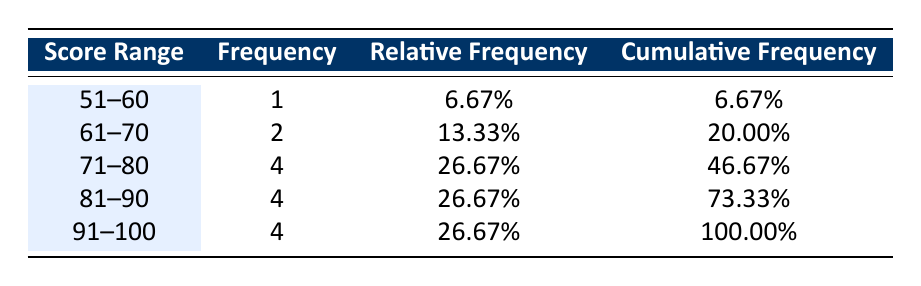What is the total number of students who scored between 81 and 90? Looking at the frequency column for the score range 81-90, there are 4 students.
Answer: 4 What percentage of students scored below 71? To find the percentage of students scored below 71, we need to sum the frequencies for score ranges 51-60 and 61-70, which adds up to 1 + 2 = 3 students. The relative frequency for these ranges is 20.00%. Thus, 3 students out of 15 total students is (3/15) * 100 = 20%.
Answer: 20.00% How many students scored 90 or higher? In the score ranges 91-100, there are 4 students. Specifically, the students who scored 90 or above include the ranges 91-100, which is 4 students total.
Answer: 4 Is it true that more students scored between 71 and 80 than those scored between 61 and 70? The frequency for the score range 71-80 is 4 students, while the frequency for the 61-70 range is 2 students. Since 4 is greater than 2, it is true.
Answer: Yes What is the cumulative frequency of students scoring above 70? To find this, we first identify the cumulative frequencies for the relevant score ranges: 71-80 (46.67%) and 81-90 (73.33%) and 91-100 (100.00%). Thus, the cumulative frequency of students scoring above 70 is 100.00%.
Answer: 100.00% What is the average score of the students who scored in the 91-100 range? There are 4 students in the 91-100 range. Their scores are 95, 92, 91, and 90. To find the average, we sum these scores: 95 + 92 + 91 + 90 = 368. Then, we divide by 4 to get the average: 368 / 4 = 92.
Answer: 92 How many score ranges have a frequency of 4? By looking at the table, we can see that three score ranges (71-80, 81-90, and 91-100) each have a frequency of 4.
Answer: 3 What is the relative frequency of students who scored between 61 and 70? From the table, the frequency for the score range 61-70 is 2. To find the relative frequency, we divide the frequency by the total number of students, which is 15. This gives us 2/15 ≈ 13.33%.
Answer: 13.33% 